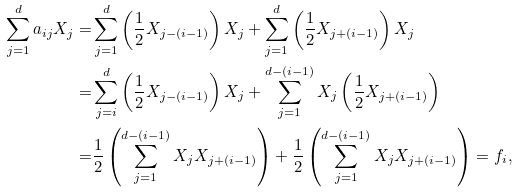<formula> <loc_0><loc_0><loc_500><loc_500>\sum _ { j = 1 } ^ { d } a _ { i j } X _ { j } = & \sum _ { j = 1 } ^ { d } \left ( \frac { 1 } { 2 } X _ { j - ( i - 1 ) } \right ) X _ { j } + \sum _ { j = 1 } ^ { d } \left ( \frac { 1 } { 2 } X _ { j + ( i - 1 ) } \right ) X _ { j } \\ = & \sum _ { j = i } ^ { d } \left ( \frac { 1 } { 2 } X _ { j - ( i - 1 ) } \right ) X _ { j } + \sum _ { j = 1 } ^ { d - ( i - 1 ) } X _ { j } \left ( \frac { 1 } { 2 } X _ { j + ( i - 1 ) } \right ) \\ = & \frac { 1 } { 2 } \left ( \sum _ { j = 1 } ^ { d - ( i - 1 ) } X _ { j } X _ { j + ( i - 1 ) } \right ) + \frac { 1 } { 2 } \left ( \sum _ { j = 1 } ^ { d - ( i - 1 ) } X _ { j } X _ { j + ( i - 1 ) } \right ) = f _ { i } ,</formula> 